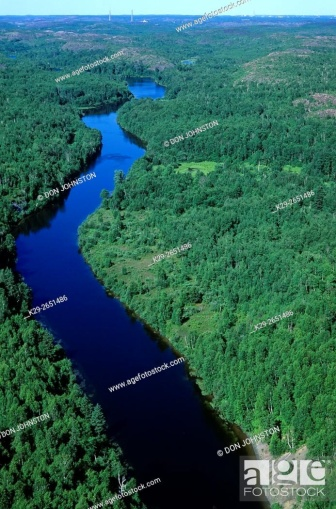Explain the visual content of the image in great detail. This image presents an aerial view of a meandering river cutting through a densely forested area. The river, a vibrant blue, contrasts starkly with the different hues of green from the surrounding foliage. Upon closer inspection, one can observe a mixture of both coniferous and deciduous trees, suggesting this might be a temperate climate. The image is taken during a time of day when the lighting is bright, indicative of a sunny day without apparent clouds. This could be a remote location given the lack of visible infrastructure, like roads or buildings, reinforcing the untouched aspect of the environment. Also, there are no clear signs of human disturbance or seasonal changes, such as fall colors or snow, which could help pinpoint the time of the year this photo was taken. 